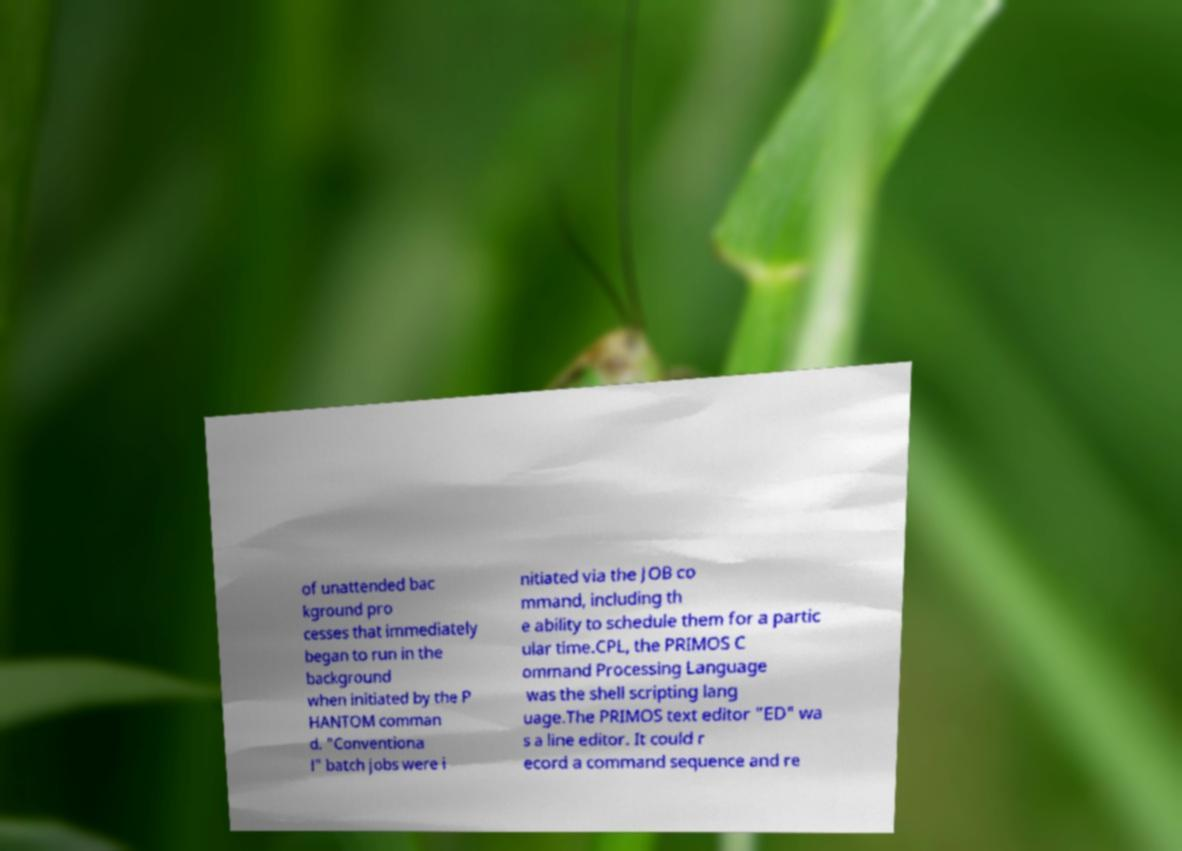Can you accurately transcribe the text from the provided image for me? of unattended bac kground pro cesses that immediately began to run in the background when initiated by the P HANTOM comman d. "Conventiona l" batch jobs were i nitiated via the JOB co mmand, including th e ability to schedule them for a partic ular time.CPL, the PRIMOS C ommand Processing Language was the shell scripting lang uage.The PRIMOS text editor "ED" wa s a line editor. It could r ecord a command sequence and re 